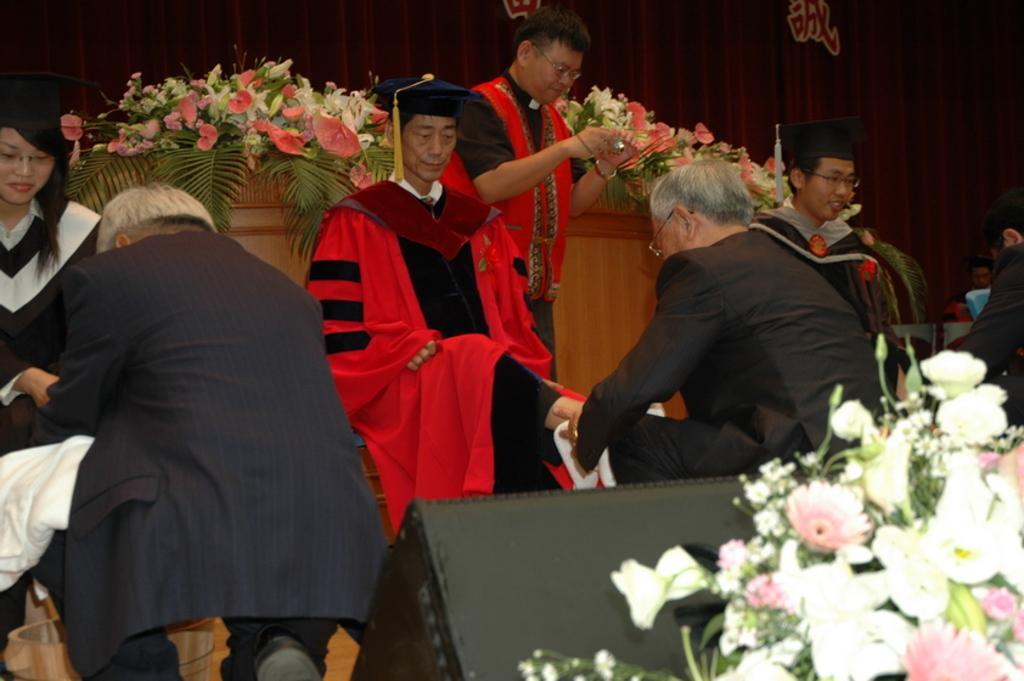Can you describe this image briefly? In this picture we can see three persons sitting here, they wore caps, we can see a person standing here, there are some flower bouquets here, in the background we can see curtain. 